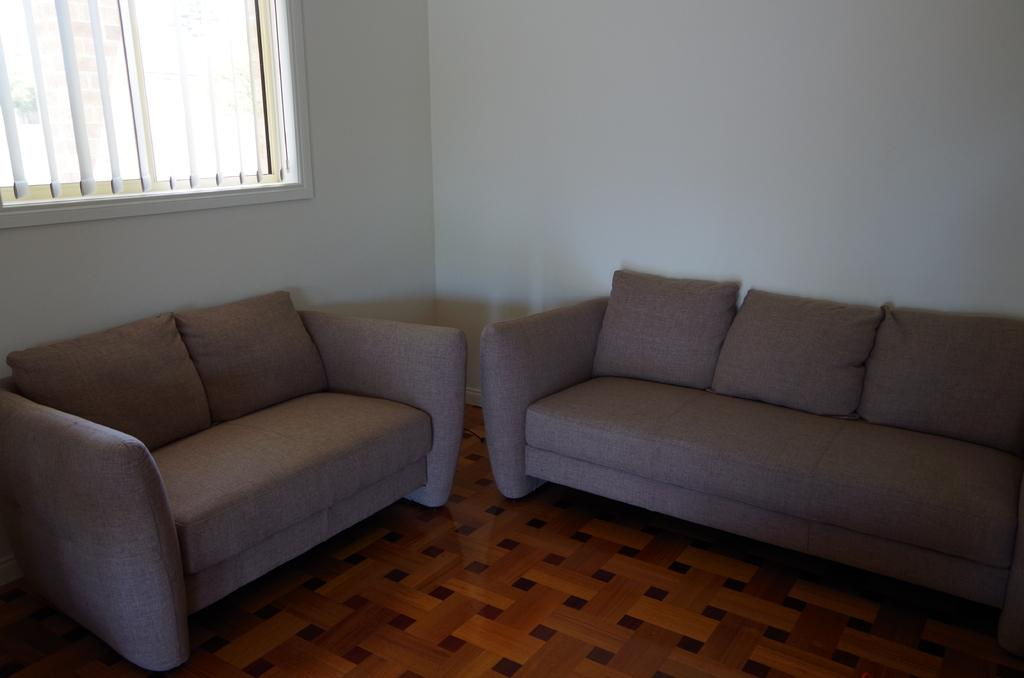Where was the image taken? The image was taken inside a room. What furniture is visible in the image? There are two couches in the image. What can be seen in the background of the image? There is a wall and a window in the background of the image. How are the window blinds attached to the window? Window blinds are attached to the window. What type of print can be seen on the board in the image? There is no board or print present in the image. 